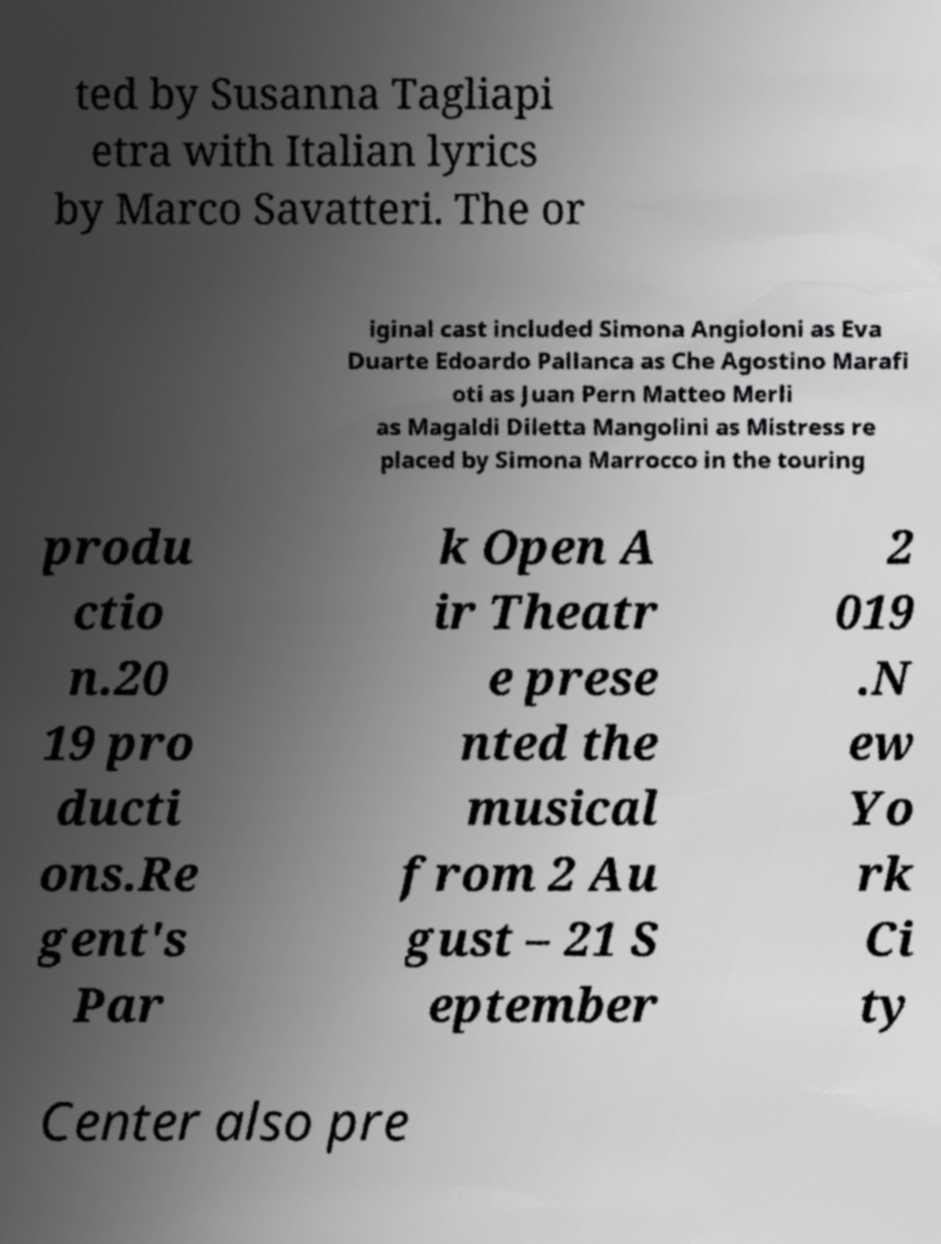What messages or text are displayed in this image? I need them in a readable, typed format. ted by Susanna Tagliapi etra with Italian lyrics by Marco Savatteri. The or iginal cast included Simona Angioloni as Eva Duarte Edoardo Pallanca as Che Agostino Marafi oti as Juan Pern Matteo Merli as Magaldi Diletta Mangolini as Mistress re placed by Simona Marrocco in the touring produ ctio n.20 19 pro ducti ons.Re gent's Par k Open A ir Theatr e prese nted the musical from 2 Au gust – 21 S eptember 2 019 .N ew Yo rk Ci ty Center also pre 